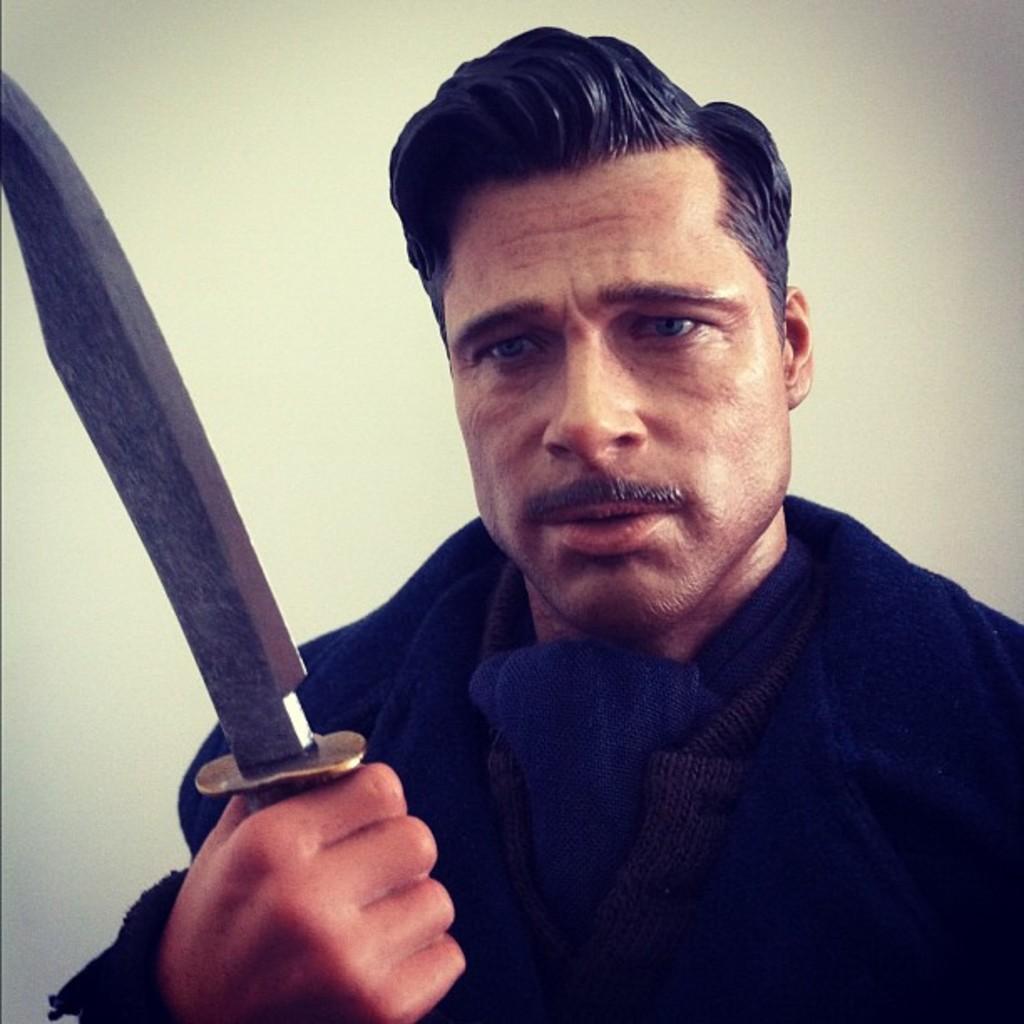In one or two sentences, can you explain what this image depicts? An idol of man holding a knife is shown in the picture. 